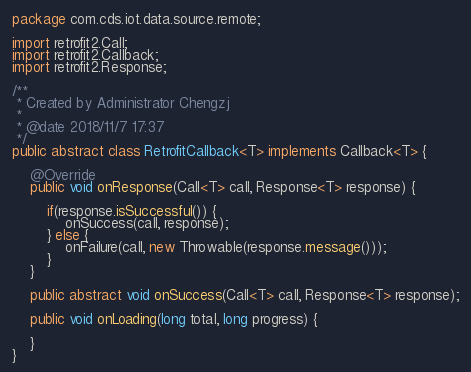Convert code to text. <code><loc_0><loc_0><loc_500><loc_500><_Java_>package com.cds.iot.data.source.remote;

import retrofit2.Call;
import retrofit2.Callback;
import retrofit2.Response;

/**
 * Created by Administrator Chengzj
 *
 * @date 2018/11/7 17:37
 */
public abstract class RetrofitCallback<T> implements Callback<T> {

    @Override
    public void onResponse(Call<T> call, Response<T> response) {

        if(response.isSuccessful()) {
            onSuccess(call, response);
        } else {
            onFailure(call, new Throwable(response.message()));
        }
    }

    public abstract void onSuccess(Call<T> call, Response<T> response);

    public void onLoading(long total, long progress) {

    }
}
</code> 